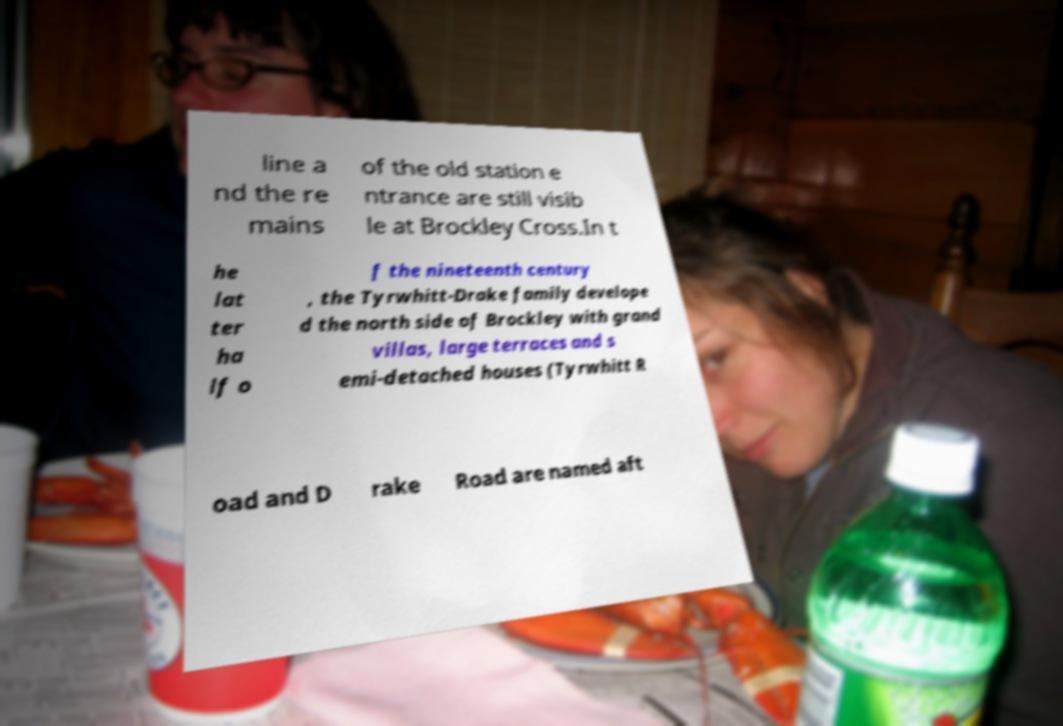For documentation purposes, I need the text within this image transcribed. Could you provide that? line a nd the re mains of the old station e ntrance are still visib le at Brockley Cross.In t he lat ter ha lf o f the nineteenth century , the Tyrwhitt-Drake family develope d the north side of Brockley with grand villas, large terraces and s emi-detached houses (Tyrwhitt R oad and D rake Road are named aft 